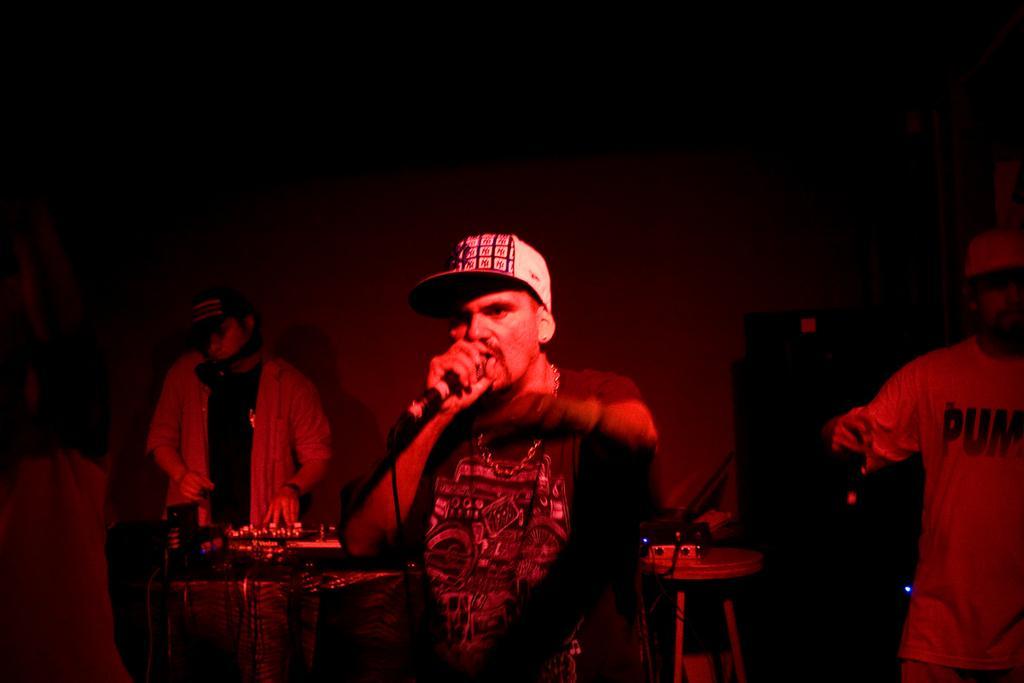Describe this image in one or two sentences. In the image there is a man in the middle singing on mic and in the background there are other men playing other musical instruments. 